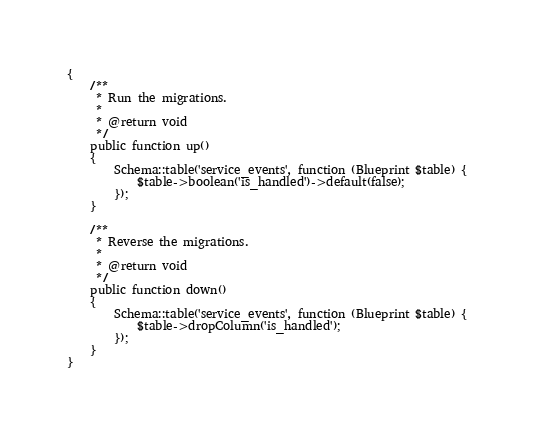<code> <loc_0><loc_0><loc_500><loc_500><_PHP_>{
    /**
     * Run the migrations.
     *
     * @return void
     */
    public function up()
    {
        Schema::table('service_events', function (Blueprint $table) {
            $table->boolean('is_handled')->default(false);
        });
    }

    /**
     * Reverse the migrations.
     *
     * @return void
     */
    public function down()
    {
        Schema::table('service_events', function (Blueprint $table) {
            $table->dropColumn('is_handled');
        });
    }
}
</code> 